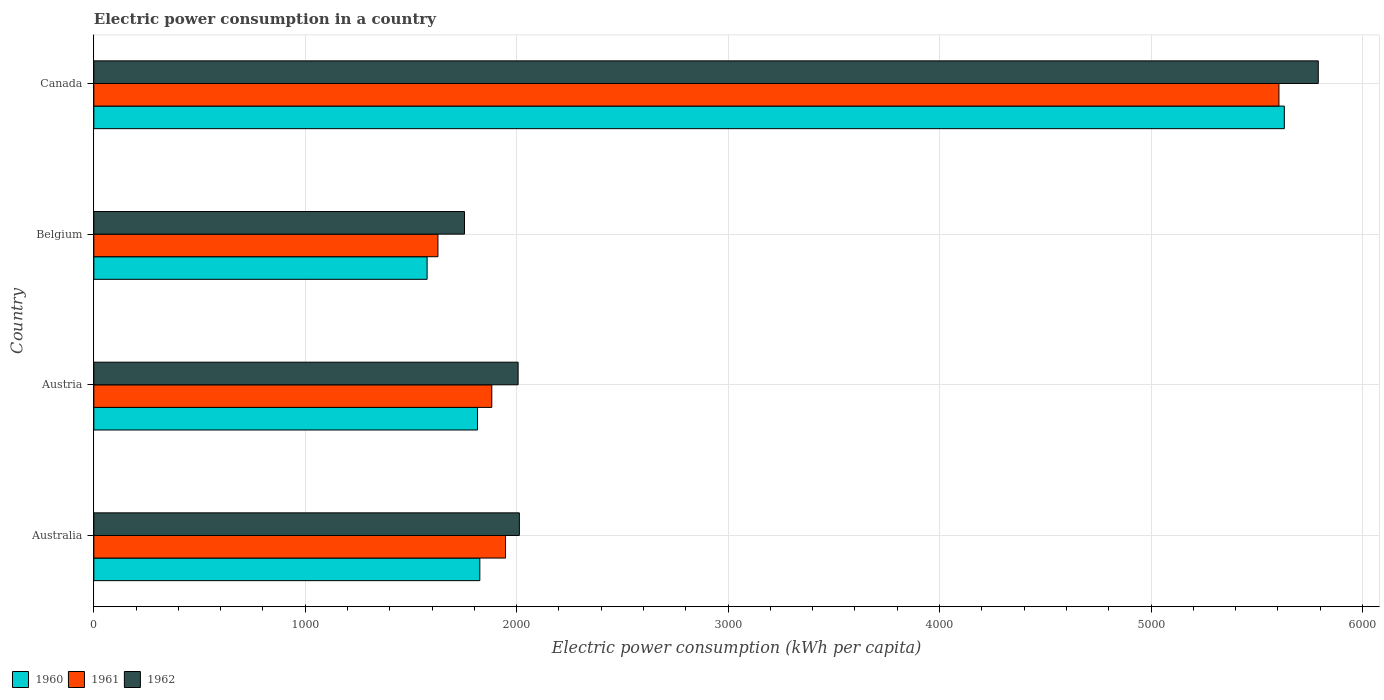How many different coloured bars are there?
Provide a succinct answer. 3. Are the number of bars per tick equal to the number of legend labels?
Give a very brief answer. Yes. Are the number of bars on each tick of the Y-axis equal?
Offer a terse response. Yes. How many bars are there on the 3rd tick from the bottom?
Your answer should be very brief. 3. What is the electric power consumption in in 1962 in Belgium?
Your answer should be compact. 1753.14. Across all countries, what is the maximum electric power consumption in in 1962?
Provide a short and direct response. 5791.12. Across all countries, what is the minimum electric power consumption in in 1961?
Ensure brevity in your answer.  1627.51. In which country was the electric power consumption in in 1960 maximum?
Keep it short and to the point. Canada. What is the total electric power consumption in in 1960 in the graph?
Provide a short and direct response. 1.08e+04. What is the difference between the electric power consumption in in 1961 in Belgium and that in Canada?
Provide a short and direct response. -3977.6. What is the difference between the electric power consumption in in 1962 in Austria and the electric power consumption in in 1961 in Australia?
Your answer should be very brief. 59.62. What is the average electric power consumption in in 1960 per country?
Your response must be concise. 2711.82. What is the difference between the electric power consumption in in 1960 and electric power consumption in in 1961 in Australia?
Ensure brevity in your answer.  -121.53. What is the ratio of the electric power consumption in in 1960 in Austria to that in Belgium?
Give a very brief answer. 1.15. Is the difference between the electric power consumption in in 1960 in Australia and Belgium greater than the difference between the electric power consumption in in 1961 in Australia and Belgium?
Ensure brevity in your answer.  No. What is the difference between the highest and the second highest electric power consumption in in 1960?
Give a very brief answer. 3805. What is the difference between the highest and the lowest electric power consumption in in 1960?
Ensure brevity in your answer.  4054.29. In how many countries, is the electric power consumption in in 1962 greater than the average electric power consumption in in 1962 taken over all countries?
Ensure brevity in your answer.  1. What does the 3rd bar from the top in Canada represents?
Your answer should be very brief. 1960. What does the 1st bar from the bottom in Belgium represents?
Your response must be concise. 1960. How many countries are there in the graph?
Your answer should be compact. 4. Are the values on the major ticks of X-axis written in scientific E-notation?
Provide a short and direct response. No. Does the graph contain any zero values?
Provide a succinct answer. No. Does the graph contain grids?
Your response must be concise. Yes. Where does the legend appear in the graph?
Give a very brief answer. Bottom left. What is the title of the graph?
Ensure brevity in your answer.  Electric power consumption in a country. What is the label or title of the X-axis?
Ensure brevity in your answer.  Electric power consumption (kWh per capita). What is the label or title of the Y-axis?
Your answer should be very brief. Country. What is the Electric power consumption (kWh per capita) in 1960 in Australia?
Give a very brief answer. 1825.63. What is the Electric power consumption (kWh per capita) of 1961 in Australia?
Ensure brevity in your answer.  1947.15. What is the Electric power consumption (kWh per capita) in 1962 in Australia?
Offer a very short reply. 2012.66. What is the Electric power consumption (kWh per capita) in 1960 in Austria?
Offer a terse response. 1814.68. What is the Electric power consumption (kWh per capita) of 1961 in Austria?
Provide a short and direct response. 1882.22. What is the Electric power consumption (kWh per capita) of 1962 in Austria?
Your response must be concise. 2006.77. What is the Electric power consumption (kWh per capita) of 1960 in Belgium?
Give a very brief answer. 1576.34. What is the Electric power consumption (kWh per capita) in 1961 in Belgium?
Your answer should be compact. 1627.51. What is the Electric power consumption (kWh per capita) of 1962 in Belgium?
Your answer should be compact. 1753.14. What is the Electric power consumption (kWh per capita) of 1960 in Canada?
Your answer should be compact. 5630.63. What is the Electric power consumption (kWh per capita) of 1961 in Canada?
Your answer should be very brief. 5605.11. What is the Electric power consumption (kWh per capita) in 1962 in Canada?
Your response must be concise. 5791.12. Across all countries, what is the maximum Electric power consumption (kWh per capita) in 1960?
Your answer should be very brief. 5630.63. Across all countries, what is the maximum Electric power consumption (kWh per capita) in 1961?
Provide a short and direct response. 5605.11. Across all countries, what is the maximum Electric power consumption (kWh per capita) in 1962?
Your answer should be very brief. 5791.12. Across all countries, what is the minimum Electric power consumption (kWh per capita) of 1960?
Your response must be concise. 1576.34. Across all countries, what is the minimum Electric power consumption (kWh per capita) of 1961?
Ensure brevity in your answer.  1627.51. Across all countries, what is the minimum Electric power consumption (kWh per capita) of 1962?
Provide a succinct answer. 1753.14. What is the total Electric power consumption (kWh per capita) of 1960 in the graph?
Make the answer very short. 1.08e+04. What is the total Electric power consumption (kWh per capita) of 1961 in the graph?
Your response must be concise. 1.11e+04. What is the total Electric power consumption (kWh per capita) in 1962 in the graph?
Your response must be concise. 1.16e+04. What is the difference between the Electric power consumption (kWh per capita) in 1960 in Australia and that in Austria?
Offer a terse response. 10.95. What is the difference between the Electric power consumption (kWh per capita) in 1961 in Australia and that in Austria?
Make the answer very short. 64.93. What is the difference between the Electric power consumption (kWh per capita) of 1962 in Australia and that in Austria?
Provide a short and direct response. 5.89. What is the difference between the Electric power consumption (kWh per capita) of 1960 in Australia and that in Belgium?
Offer a terse response. 249.29. What is the difference between the Electric power consumption (kWh per capita) of 1961 in Australia and that in Belgium?
Provide a succinct answer. 319.64. What is the difference between the Electric power consumption (kWh per capita) of 1962 in Australia and that in Belgium?
Keep it short and to the point. 259.52. What is the difference between the Electric power consumption (kWh per capita) of 1960 in Australia and that in Canada?
Your answer should be very brief. -3805. What is the difference between the Electric power consumption (kWh per capita) in 1961 in Australia and that in Canada?
Offer a very short reply. -3657.96. What is the difference between the Electric power consumption (kWh per capita) in 1962 in Australia and that in Canada?
Provide a short and direct response. -3778.46. What is the difference between the Electric power consumption (kWh per capita) of 1960 in Austria and that in Belgium?
Provide a succinct answer. 238.34. What is the difference between the Electric power consumption (kWh per capita) in 1961 in Austria and that in Belgium?
Offer a terse response. 254.71. What is the difference between the Electric power consumption (kWh per capita) of 1962 in Austria and that in Belgium?
Make the answer very short. 253.63. What is the difference between the Electric power consumption (kWh per capita) in 1960 in Austria and that in Canada?
Offer a very short reply. -3815.95. What is the difference between the Electric power consumption (kWh per capita) in 1961 in Austria and that in Canada?
Make the answer very short. -3722.89. What is the difference between the Electric power consumption (kWh per capita) of 1962 in Austria and that in Canada?
Ensure brevity in your answer.  -3784.35. What is the difference between the Electric power consumption (kWh per capita) of 1960 in Belgium and that in Canada?
Make the answer very short. -4054.29. What is the difference between the Electric power consumption (kWh per capita) of 1961 in Belgium and that in Canada?
Offer a very short reply. -3977.6. What is the difference between the Electric power consumption (kWh per capita) of 1962 in Belgium and that in Canada?
Keep it short and to the point. -4037.98. What is the difference between the Electric power consumption (kWh per capita) in 1960 in Australia and the Electric power consumption (kWh per capita) in 1961 in Austria?
Make the answer very short. -56.6. What is the difference between the Electric power consumption (kWh per capita) in 1960 in Australia and the Electric power consumption (kWh per capita) in 1962 in Austria?
Make the answer very short. -181.14. What is the difference between the Electric power consumption (kWh per capita) in 1961 in Australia and the Electric power consumption (kWh per capita) in 1962 in Austria?
Give a very brief answer. -59.62. What is the difference between the Electric power consumption (kWh per capita) in 1960 in Australia and the Electric power consumption (kWh per capita) in 1961 in Belgium?
Give a very brief answer. 198.11. What is the difference between the Electric power consumption (kWh per capita) in 1960 in Australia and the Electric power consumption (kWh per capita) in 1962 in Belgium?
Keep it short and to the point. 72.48. What is the difference between the Electric power consumption (kWh per capita) of 1961 in Australia and the Electric power consumption (kWh per capita) of 1962 in Belgium?
Your answer should be very brief. 194.01. What is the difference between the Electric power consumption (kWh per capita) of 1960 in Australia and the Electric power consumption (kWh per capita) of 1961 in Canada?
Your answer should be compact. -3779.49. What is the difference between the Electric power consumption (kWh per capita) in 1960 in Australia and the Electric power consumption (kWh per capita) in 1962 in Canada?
Give a very brief answer. -3965.5. What is the difference between the Electric power consumption (kWh per capita) of 1961 in Australia and the Electric power consumption (kWh per capita) of 1962 in Canada?
Provide a short and direct response. -3843.97. What is the difference between the Electric power consumption (kWh per capita) in 1960 in Austria and the Electric power consumption (kWh per capita) in 1961 in Belgium?
Provide a succinct answer. 187.16. What is the difference between the Electric power consumption (kWh per capita) of 1960 in Austria and the Electric power consumption (kWh per capita) of 1962 in Belgium?
Provide a short and direct response. 61.53. What is the difference between the Electric power consumption (kWh per capita) of 1961 in Austria and the Electric power consumption (kWh per capita) of 1962 in Belgium?
Your response must be concise. 129.08. What is the difference between the Electric power consumption (kWh per capita) of 1960 in Austria and the Electric power consumption (kWh per capita) of 1961 in Canada?
Your response must be concise. -3790.44. What is the difference between the Electric power consumption (kWh per capita) of 1960 in Austria and the Electric power consumption (kWh per capita) of 1962 in Canada?
Ensure brevity in your answer.  -3976.45. What is the difference between the Electric power consumption (kWh per capita) in 1961 in Austria and the Electric power consumption (kWh per capita) in 1962 in Canada?
Give a very brief answer. -3908.9. What is the difference between the Electric power consumption (kWh per capita) in 1960 in Belgium and the Electric power consumption (kWh per capita) in 1961 in Canada?
Provide a short and direct response. -4028.77. What is the difference between the Electric power consumption (kWh per capita) of 1960 in Belgium and the Electric power consumption (kWh per capita) of 1962 in Canada?
Your answer should be very brief. -4214.79. What is the difference between the Electric power consumption (kWh per capita) in 1961 in Belgium and the Electric power consumption (kWh per capita) in 1962 in Canada?
Offer a very short reply. -4163.61. What is the average Electric power consumption (kWh per capita) in 1960 per country?
Your answer should be compact. 2711.82. What is the average Electric power consumption (kWh per capita) in 1961 per country?
Provide a succinct answer. 2765.5. What is the average Electric power consumption (kWh per capita) in 1962 per country?
Your answer should be compact. 2890.93. What is the difference between the Electric power consumption (kWh per capita) in 1960 and Electric power consumption (kWh per capita) in 1961 in Australia?
Keep it short and to the point. -121.53. What is the difference between the Electric power consumption (kWh per capita) in 1960 and Electric power consumption (kWh per capita) in 1962 in Australia?
Your answer should be compact. -187.03. What is the difference between the Electric power consumption (kWh per capita) in 1961 and Electric power consumption (kWh per capita) in 1962 in Australia?
Keep it short and to the point. -65.51. What is the difference between the Electric power consumption (kWh per capita) in 1960 and Electric power consumption (kWh per capita) in 1961 in Austria?
Make the answer very short. -67.55. What is the difference between the Electric power consumption (kWh per capita) of 1960 and Electric power consumption (kWh per capita) of 1962 in Austria?
Provide a short and direct response. -192.09. What is the difference between the Electric power consumption (kWh per capita) of 1961 and Electric power consumption (kWh per capita) of 1962 in Austria?
Provide a succinct answer. -124.55. What is the difference between the Electric power consumption (kWh per capita) in 1960 and Electric power consumption (kWh per capita) in 1961 in Belgium?
Offer a very short reply. -51.17. What is the difference between the Electric power consumption (kWh per capita) in 1960 and Electric power consumption (kWh per capita) in 1962 in Belgium?
Give a very brief answer. -176.81. What is the difference between the Electric power consumption (kWh per capita) in 1961 and Electric power consumption (kWh per capita) in 1962 in Belgium?
Your answer should be very brief. -125.63. What is the difference between the Electric power consumption (kWh per capita) of 1960 and Electric power consumption (kWh per capita) of 1961 in Canada?
Ensure brevity in your answer.  25.52. What is the difference between the Electric power consumption (kWh per capita) in 1960 and Electric power consumption (kWh per capita) in 1962 in Canada?
Offer a very short reply. -160.5. What is the difference between the Electric power consumption (kWh per capita) in 1961 and Electric power consumption (kWh per capita) in 1962 in Canada?
Your response must be concise. -186.01. What is the ratio of the Electric power consumption (kWh per capita) in 1961 in Australia to that in Austria?
Make the answer very short. 1.03. What is the ratio of the Electric power consumption (kWh per capita) of 1960 in Australia to that in Belgium?
Offer a terse response. 1.16. What is the ratio of the Electric power consumption (kWh per capita) of 1961 in Australia to that in Belgium?
Your answer should be compact. 1.2. What is the ratio of the Electric power consumption (kWh per capita) of 1962 in Australia to that in Belgium?
Offer a very short reply. 1.15. What is the ratio of the Electric power consumption (kWh per capita) in 1960 in Australia to that in Canada?
Make the answer very short. 0.32. What is the ratio of the Electric power consumption (kWh per capita) in 1961 in Australia to that in Canada?
Your answer should be compact. 0.35. What is the ratio of the Electric power consumption (kWh per capita) of 1962 in Australia to that in Canada?
Provide a short and direct response. 0.35. What is the ratio of the Electric power consumption (kWh per capita) in 1960 in Austria to that in Belgium?
Make the answer very short. 1.15. What is the ratio of the Electric power consumption (kWh per capita) of 1961 in Austria to that in Belgium?
Keep it short and to the point. 1.16. What is the ratio of the Electric power consumption (kWh per capita) in 1962 in Austria to that in Belgium?
Provide a succinct answer. 1.14. What is the ratio of the Electric power consumption (kWh per capita) of 1960 in Austria to that in Canada?
Ensure brevity in your answer.  0.32. What is the ratio of the Electric power consumption (kWh per capita) in 1961 in Austria to that in Canada?
Make the answer very short. 0.34. What is the ratio of the Electric power consumption (kWh per capita) in 1962 in Austria to that in Canada?
Offer a terse response. 0.35. What is the ratio of the Electric power consumption (kWh per capita) of 1960 in Belgium to that in Canada?
Your response must be concise. 0.28. What is the ratio of the Electric power consumption (kWh per capita) in 1961 in Belgium to that in Canada?
Give a very brief answer. 0.29. What is the ratio of the Electric power consumption (kWh per capita) of 1962 in Belgium to that in Canada?
Your response must be concise. 0.3. What is the difference between the highest and the second highest Electric power consumption (kWh per capita) of 1960?
Give a very brief answer. 3805. What is the difference between the highest and the second highest Electric power consumption (kWh per capita) in 1961?
Make the answer very short. 3657.96. What is the difference between the highest and the second highest Electric power consumption (kWh per capita) of 1962?
Your answer should be compact. 3778.46. What is the difference between the highest and the lowest Electric power consumption (kWh per capita) of 1960?
Provide a short and direct response. 4054.29. What is the difference between the highest and the lowest Electric power consumption (kWh per capita) in 1961?
Your answer should be very brief. 3977.6. What is the difference between the highest and the lowest Electric power consumption (kWh per capita) of 1962?
Offer a very short reply. 4037.98. 